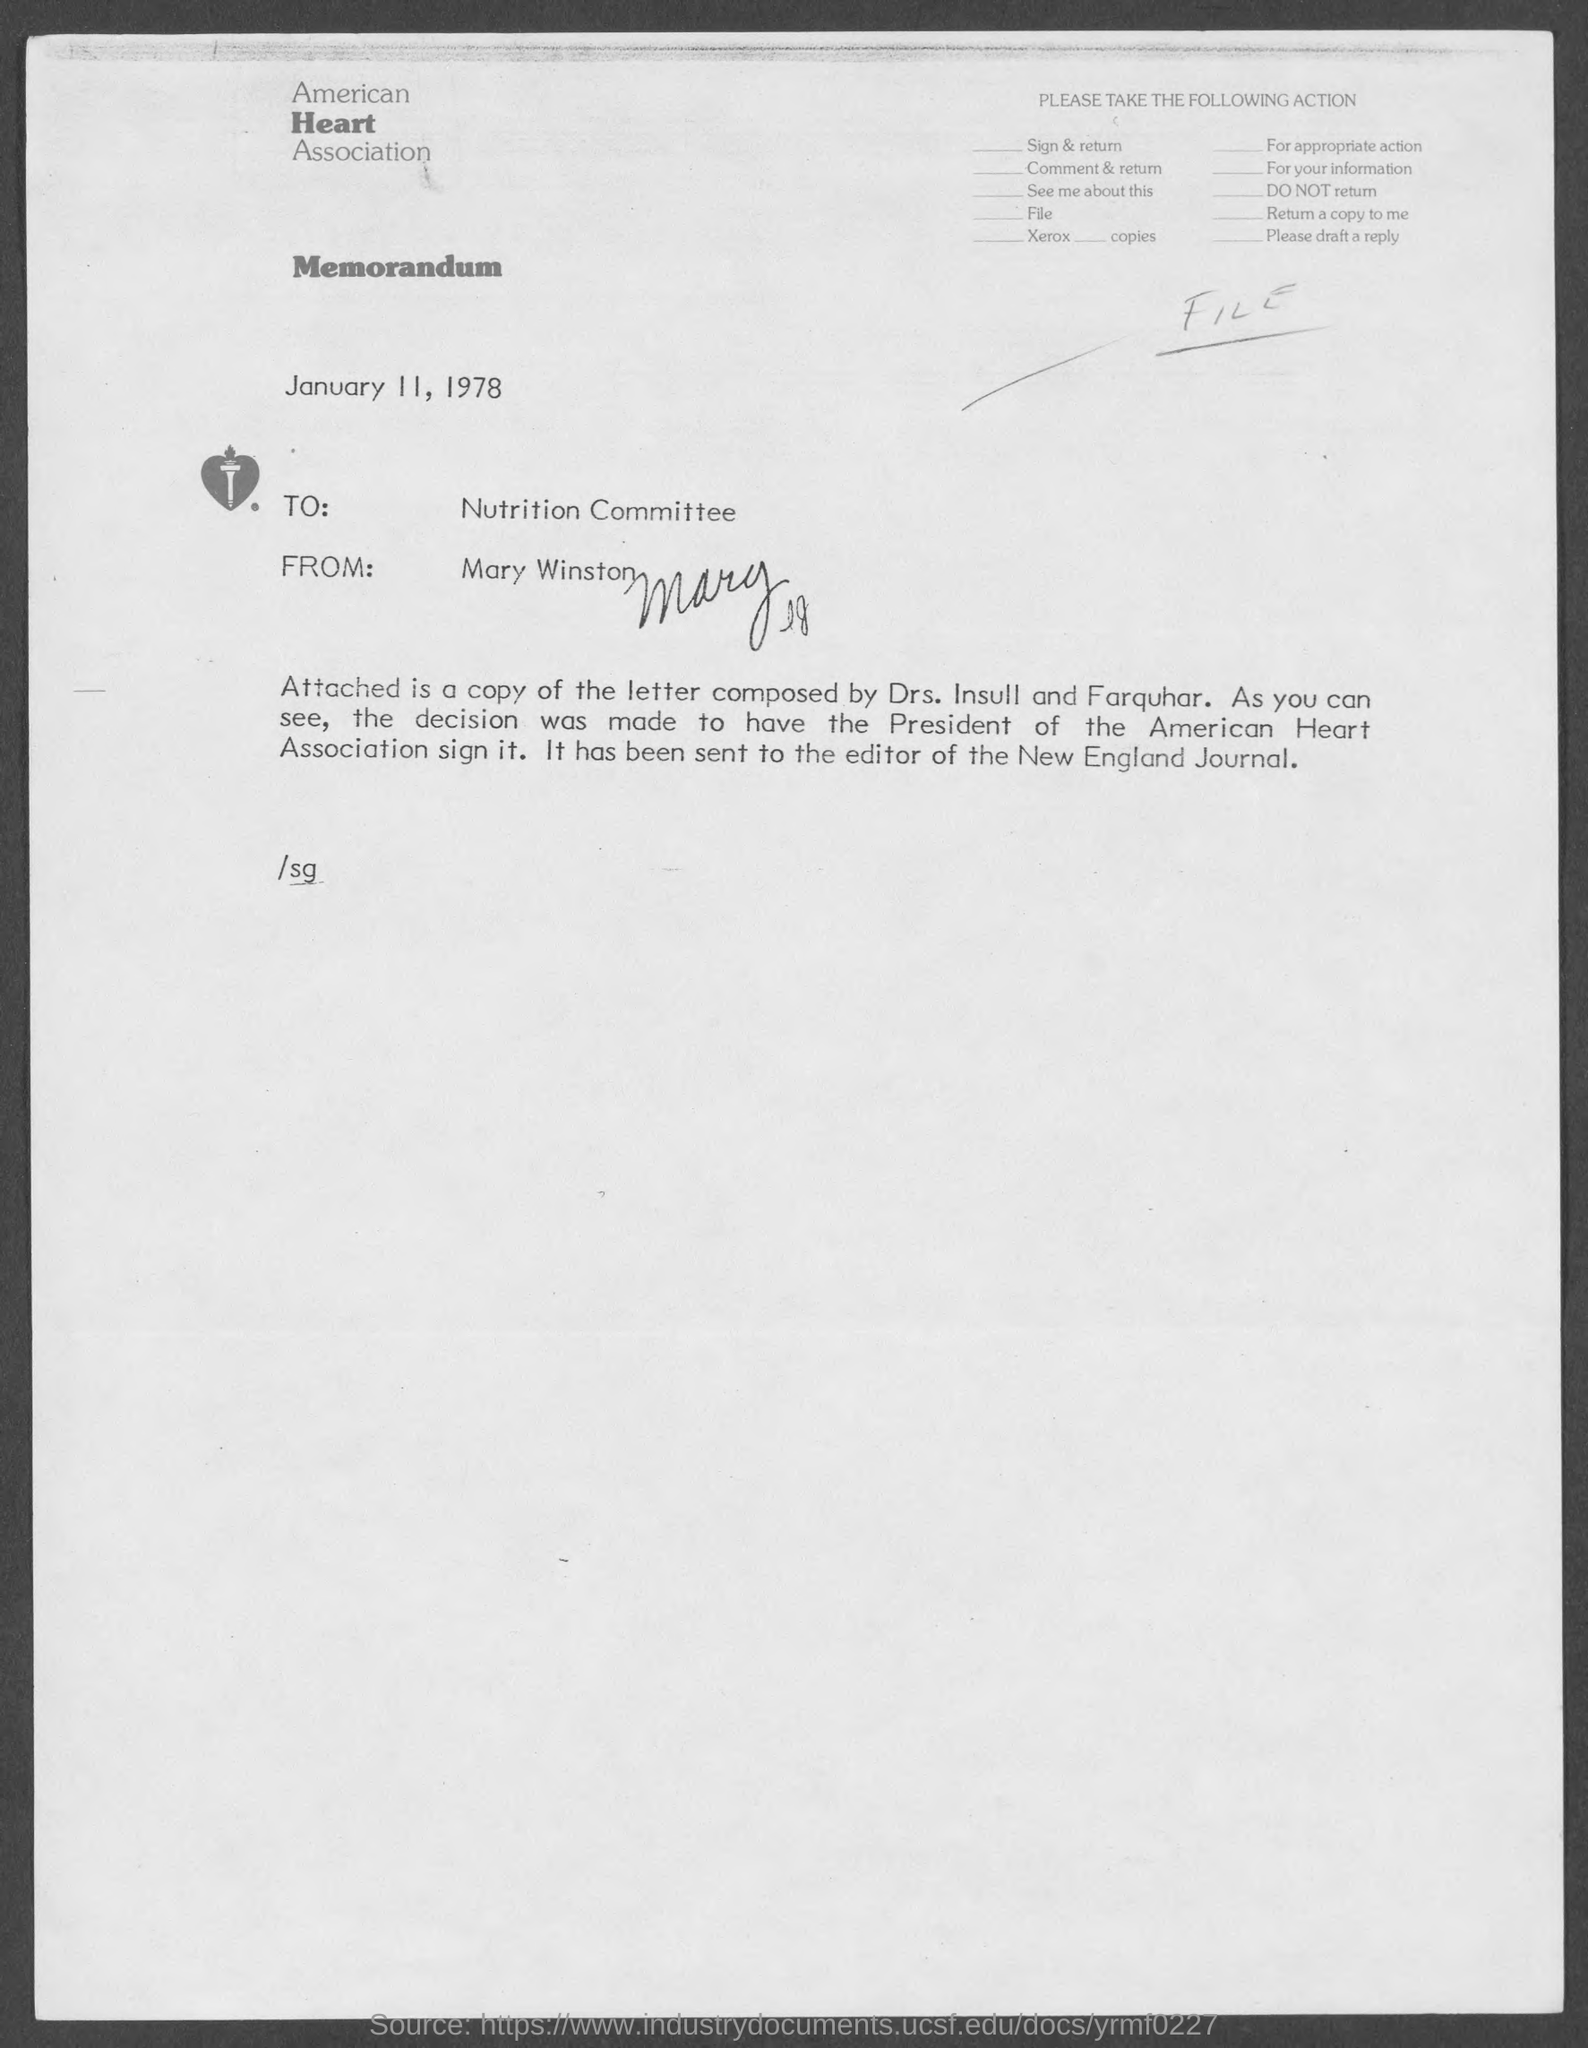What is the name of the heart association at top of the page ?
Offer a terse response. American Heart Association. From whom is this memorandum from ?
Ensure brevity in your answer.  Mary Winston. When is the memorandum dated?
Your answer should be compact. January 11, 1978. To whom is this memorandum written to?
Offer a very short reply. Nutrition Committee. 